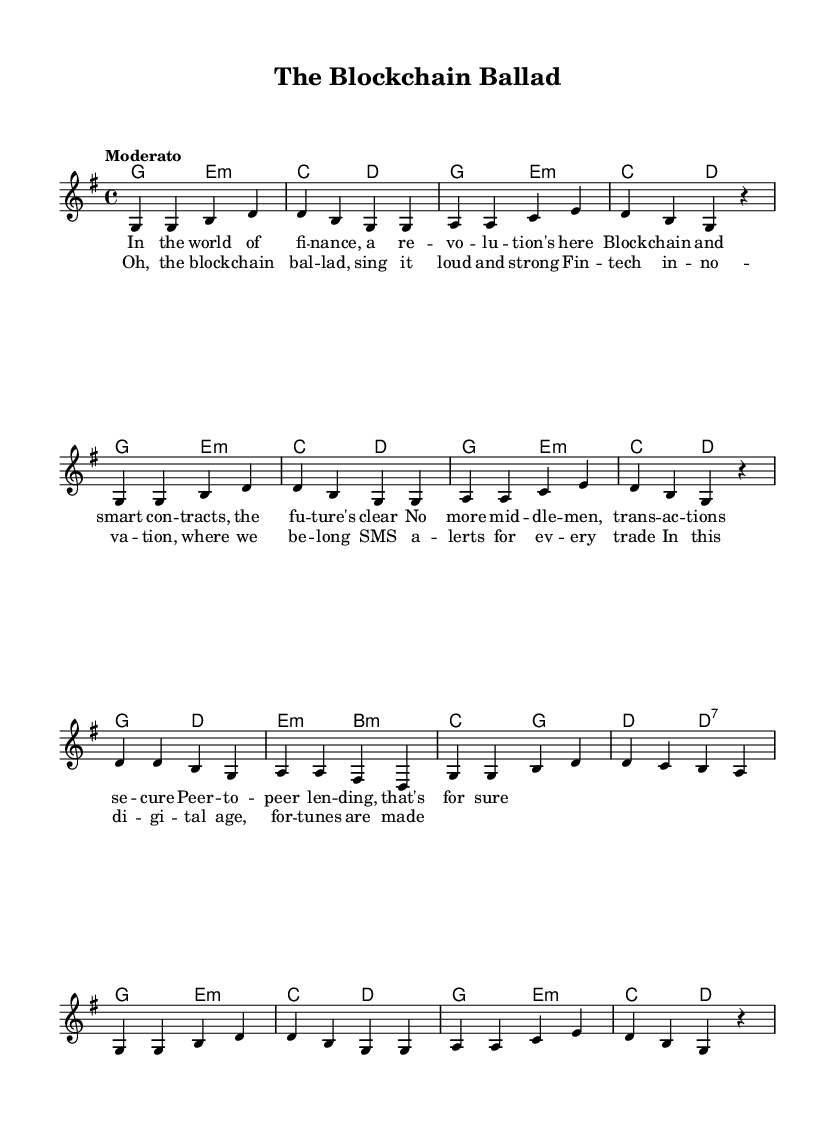What is the key signature of this music? The key signature is G major, which has one sharp (F#). This can be found at the beginning of the music sheet, where the key signature is indicated.
Answer: G major What is the time signature of this music? The time signature is 4/4, indicated by the notation at the beginning of the score. This means there are four beats in each measure and the quarter note receives one beat.
Answer: 4/4 What is the tempo marking for this music? The tempo marking is "Moderato." This indicates a moderate pace for the piece. The tempo indication is usually specified near the beginning of the score and describes how fast the music should be played.
Answer: Moderato How many measures are in the verse? There are 8 measures in the verse section. Each measure is separated by vertical lines in the sheet music, and by counting those divisions in the verse, we see there are 8 distinct measures.
Answer: 8 How many different harmonies are used in the song? The song uses four different harmonies: G, E minor, C, and D. These can be identified in the chord section where different chords appear in sequence.
Answer: Four What lyric section appears after the verse? The chorus appears after the verse. This is identified in the structure of the lyrics, where the chorus follows the verse in the layout of the sheet music.
Answer: Chorus How do the themes of the lyrics relate to the music's style? The lyrics reflect a modern take on traditional themes of folk music, focusing on finance and technology, which is characteristic of contemporary folk songs. It engages with current issues while maintaining the narrative style typical in folk music.
Answer: Contemporary folk themes 